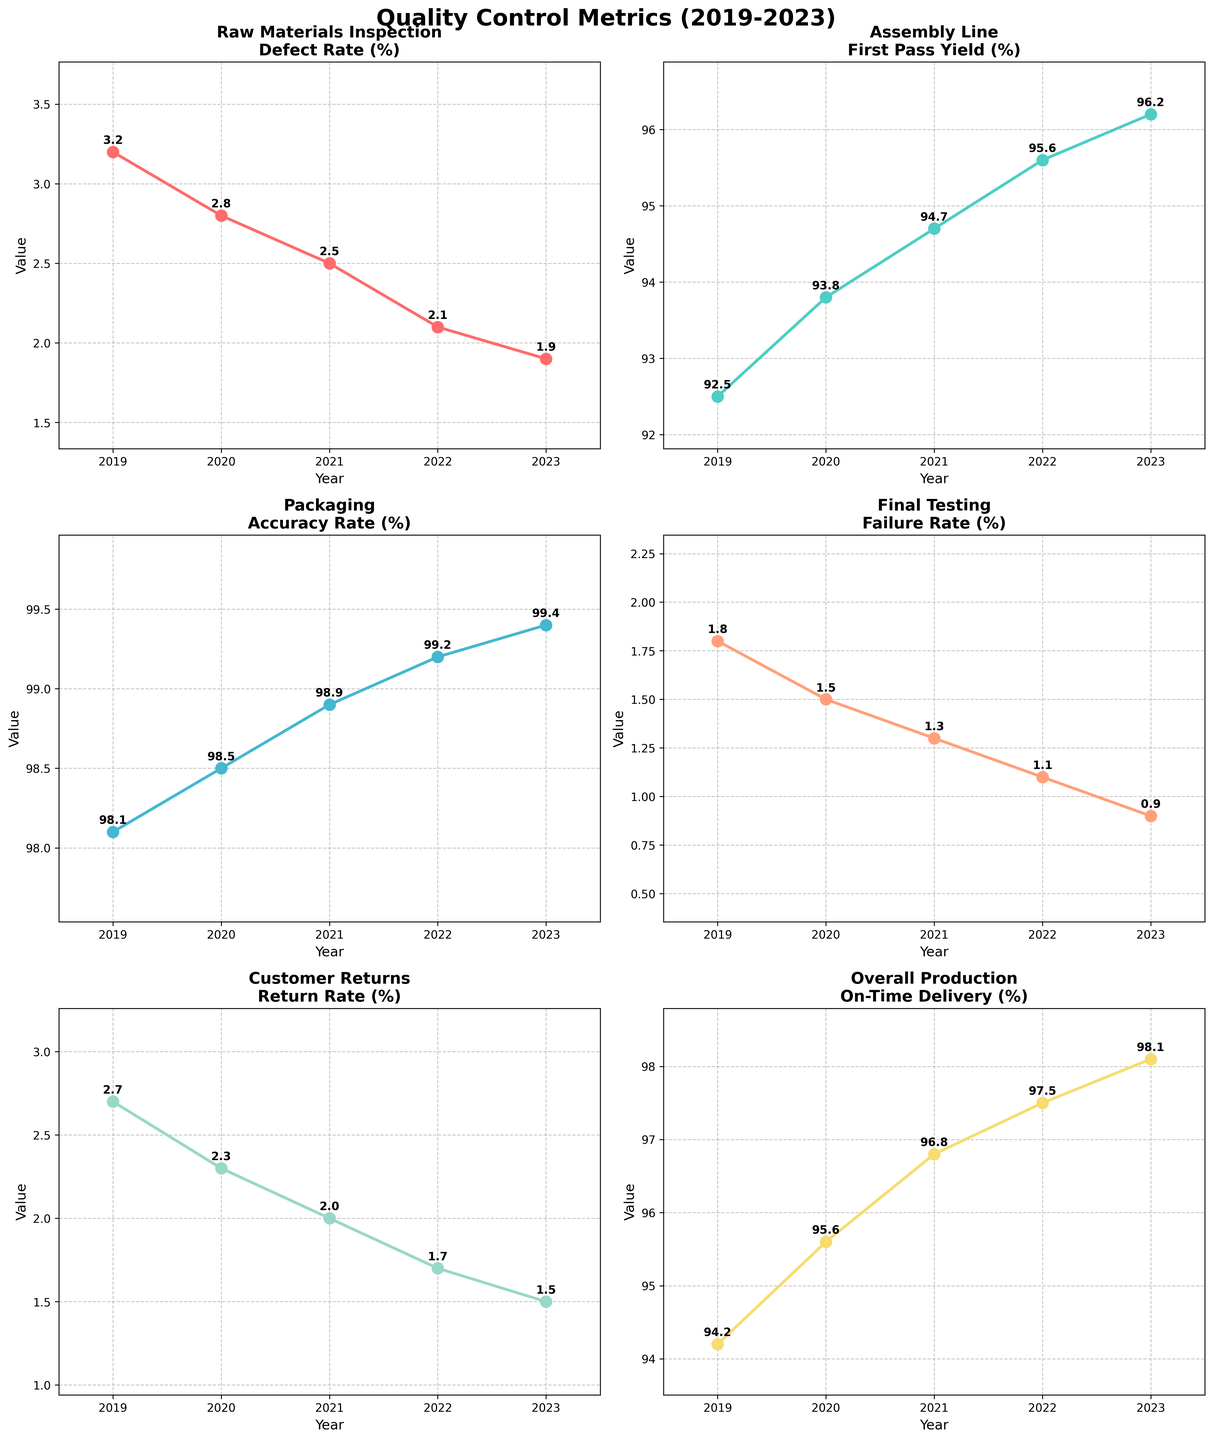How does the defect rate in Raw Materials Inspection change from 2019 to 2023? Look at the subplot for Raw Materials Inspection. Notice the values for defect rates for each year's data point and observe the trend.
Answer: The defect rate decreases What is the highest First Pass Yield percentage among the years displayed for the Assembly Line? Refer to the subplot for Assembly Line. Check the First Pass Yield percentages from 2019 to 2023 and identify the highest value.
Answer: 96.2% Compare the Final Testing failure rate in 2020 to that in 2023. Which year has a lower rate? Examine the failure rates in the Final Testing subplot for the years 2020 and 2023. Identify the one with the lower value.
Answer: 2023 What is the average On-Time Delivery percentage from 2019 to 2023? Find the On-Time Delivery percentages in the corresponding subplot for each of the years 2019, 2020, 2021, 2022, and 2023. Sum these values and then divide by 5 to compute the average.
Answer: 96.44% Which stage shows the least improvement in its metric from 2019 to 2023? Compare the changes in metrics from 2019 to 2023 for each stage by calculating the difference for each subplot. Identify the stage with the smallest change.
Answer: Packaging How does the Return Rate change from 2019 to 2023 for Customer Returns? Check the subplot for Customer Returns. Observe the Return Rate percentages for each year and identify the trend.
Answer: The Return Rate decreases Looking at the entire figure, which stage shows a consistent improvement without any fluctuations from 2019 to 2023? Observe each subplot and check for stages where the metric consistently improves each year without any fluctuations.
Answer: Packaging In which year did the Accuracy Rate in Packaging achieve the highest value? Locate the values in the Packaging subplot and identify the year with the highest Accuracy Rate.
Answer: 2023 Overall, does the trend in metrics for the stages indicate improvement or decline from 2019 to 2023? Evaluate the trend in each subplot and check whether each metric improves (increases or decreases favorably) over the years from 2019 to 2023.
Answer: Improvement What is the difference in Defect Rate between 2019 and 2023 for Raw Materials Inspection? Look at the values for 2019 and 2023 in the Raw Materials Inspection subplot and subtract the 2023 value from the 2019 value to find the difference.
Answer: 1.3 